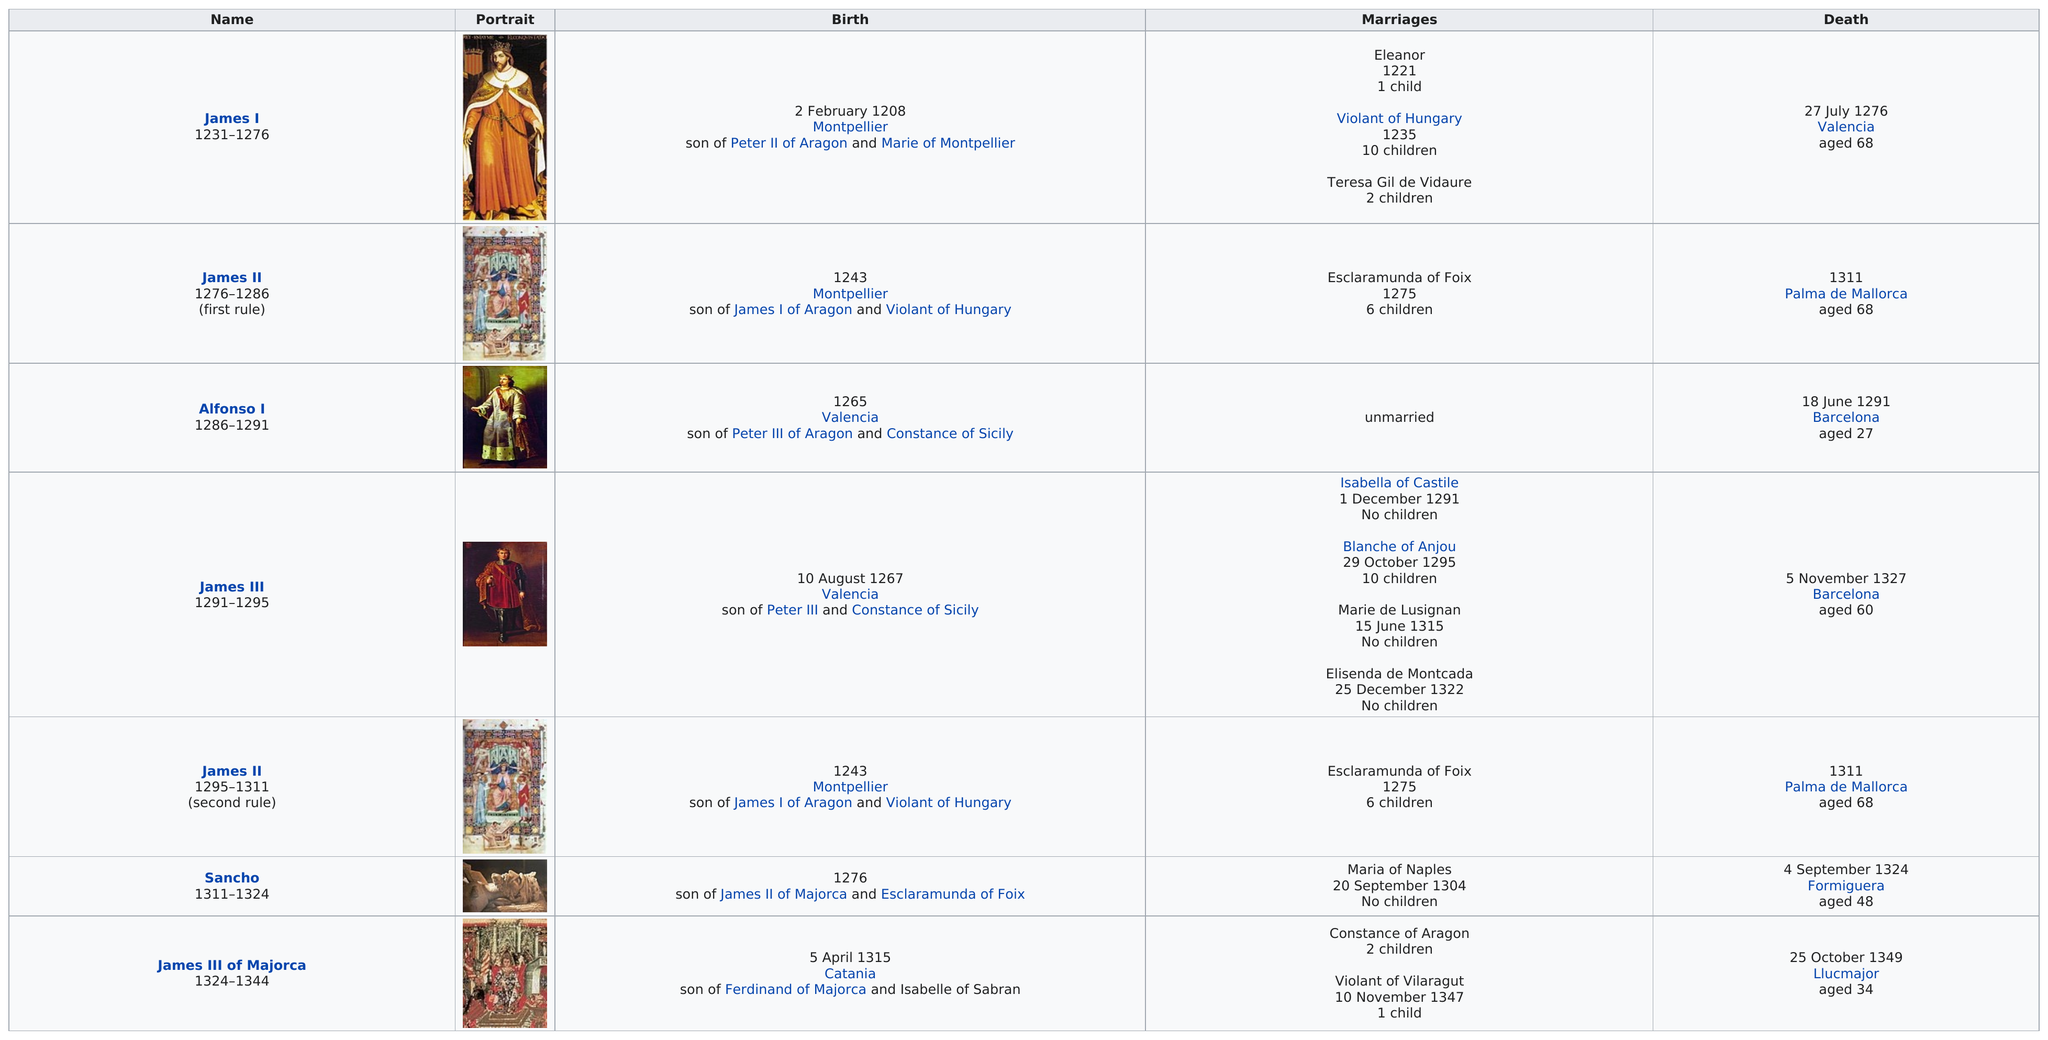Specify some key components in this picture. James I and James II both died at the age of 68. James II was in power for a total of 26 years, including two separate periods of rule. James II came to power after the rule of James III. Alfonso I and Sancho I were two monarchs who did not have any children. The name that is situated above James III and below James II is Alfonso I. 